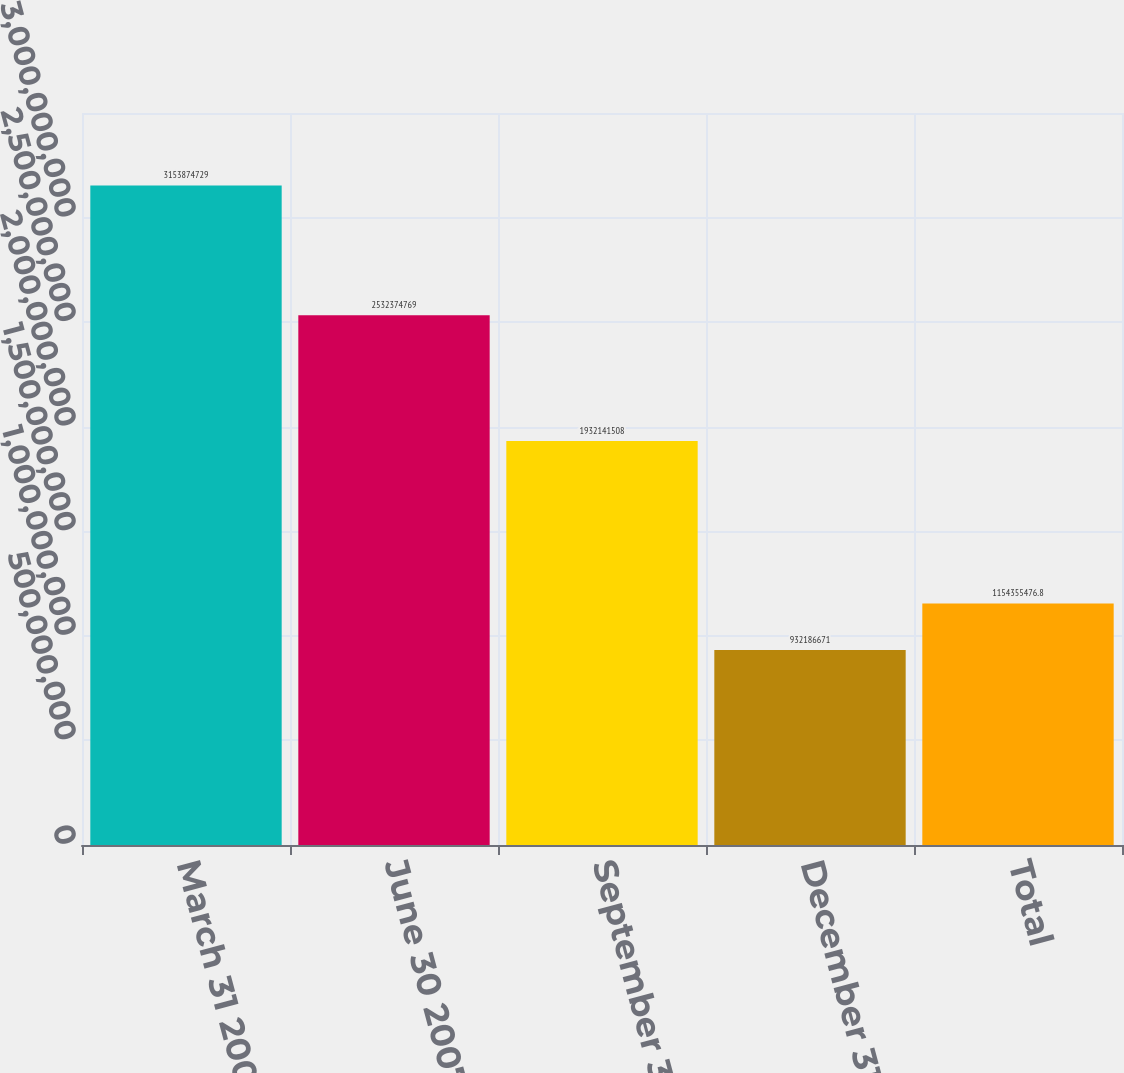Convert chart. <chart><loc_0><loc_0><loc_500><loc_500><bar_chart><fcel>March 31 2007<fcel>June 30 2007<fcel>September 30 2007<fcel>December 31 2007<fcel>Total<nl><fcel>3.15387e+09<fcel>2.53237e+09<fcel>1.93214e+09<fcel>9.32187e+08<fcel>1.15436e+09<nl></chart> 